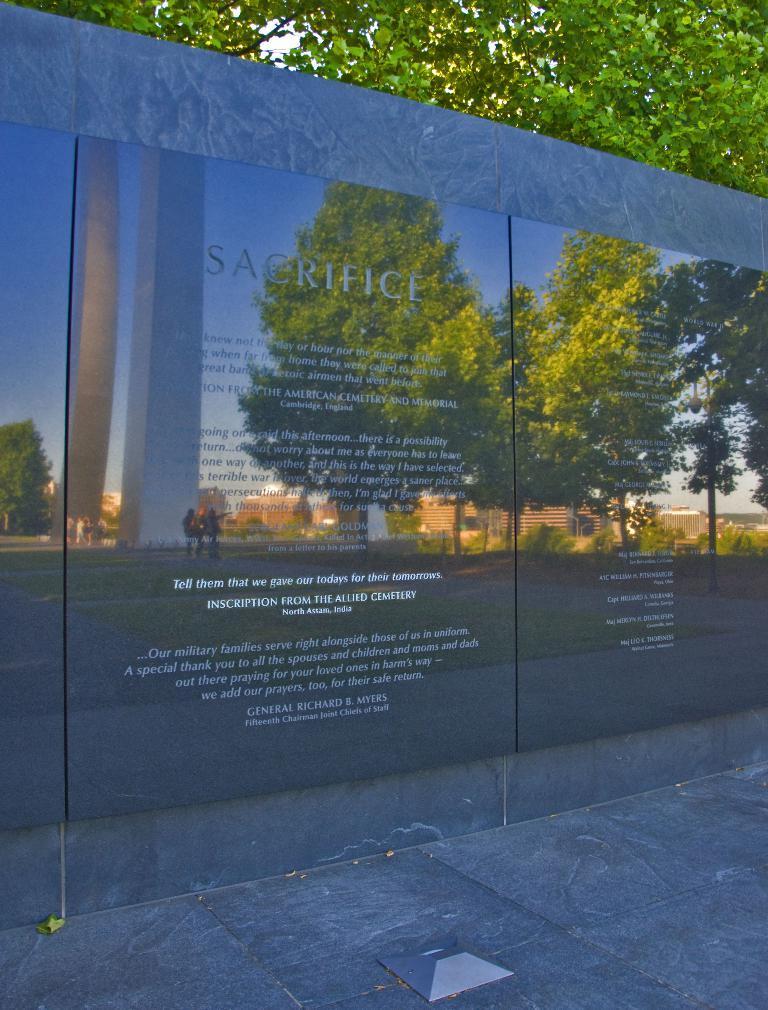Describe this image in one or two sentences. In the image we can see there are black marble stone on the wall, matter is written on the black marble stone and its written ¨Sacrifice¨. There is reflection of trees and buildings. Behind there are trees. 